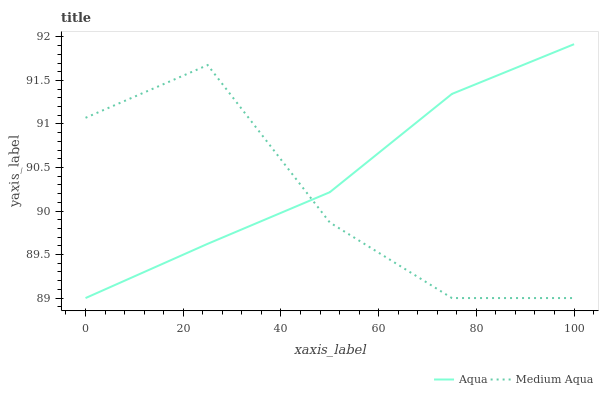Does Medium Aqua have the minimum area under the curve?
Answer yes or no. Yes. Does Aqua have the maximum area under the curve?
Answer yes or no. Yes. Does Aqua have the minimum area under the curve?
Answer yes or no. No. Is Aqua the smoothest?
Answer yes or no. Yes. Is Medium Aqua the roughest?
Answer yes or no. Yes. Is Aqua the roughest?
Answer yes or no. No. Does Medium Aqua have the lowest value?
Answer yes or no. Yes. Does Aqua have the highest value?
Answer yes or no. Yes. Does Aqua intersect Medium Aqua?
Answer yes or no. Yes. Is Aqua less than Medium Aqua?
Answer yes or no. No. Is Aqua greater than Medium Aqua?
Answer yes or no. No. 